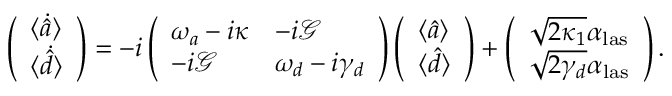Convert formula to latex. <formula><loc_0><loc_0><loc_500><loc_500>\left ( \begin{array} { l } { \langle \dot { \hat { a } } \rangle } \\ { \langle \dot { \hat { d } } \rangle } \end{array} \right ) = - i \left ( \begin{array} { l l } { \omega _ { a } - i \kappa } & { - i \mathcal { G } } \\ { - i \mathcal { G } } & { \omega _ { d } - i \gamma _ { d } } \end{array} \right ) \left ( \begin{array} { l } { \langle { \hat { a } } \rangle } \\ { \langle { \hat { d } } \rangle } \end{array} \right ) + \left ( \begin{array} { l } { \sqrt { 2 \kappa _ { 1 } } \alpha _ { l a s } } \\ { \sqrt { 2 \gamma _ { d } } \alpha _ { l a s } } \end{array} \right ) .</formula> 